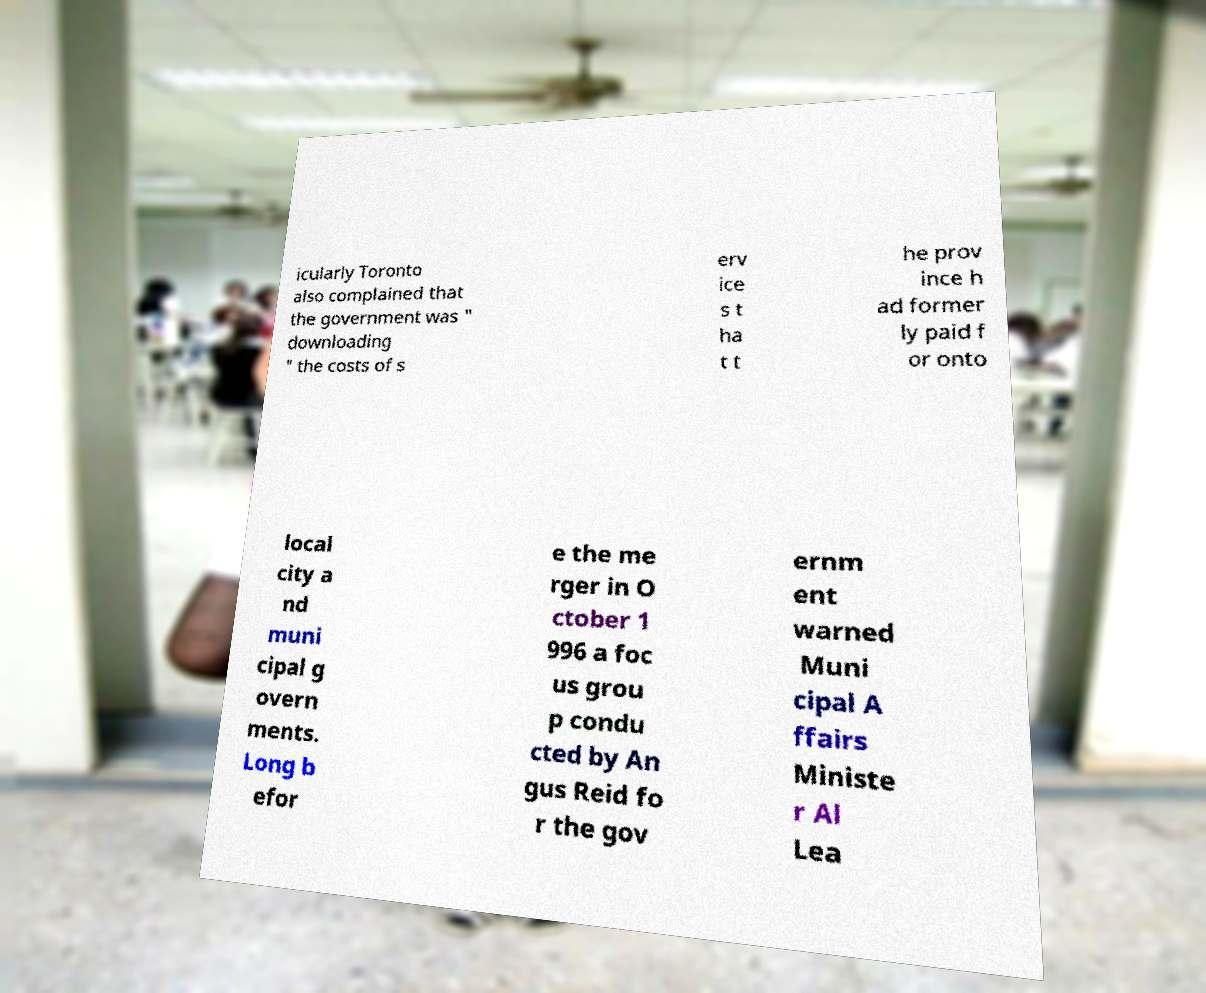What messages or text are displayed in this image? I need them in a readable, typed format. icularly Toronto also complained that the government was " downloading " the costs of s erv ice s t ha t t he prov ince h ad former ly paid f or onto local city a nd muni cipal g overn ments. Long b efor e the me rger in O ctober 1 996 a foc us grou p condu cted by An gus Reid fo r the gov ernm ent warned Muni cipal A ffairs Ministe r Al Lea 